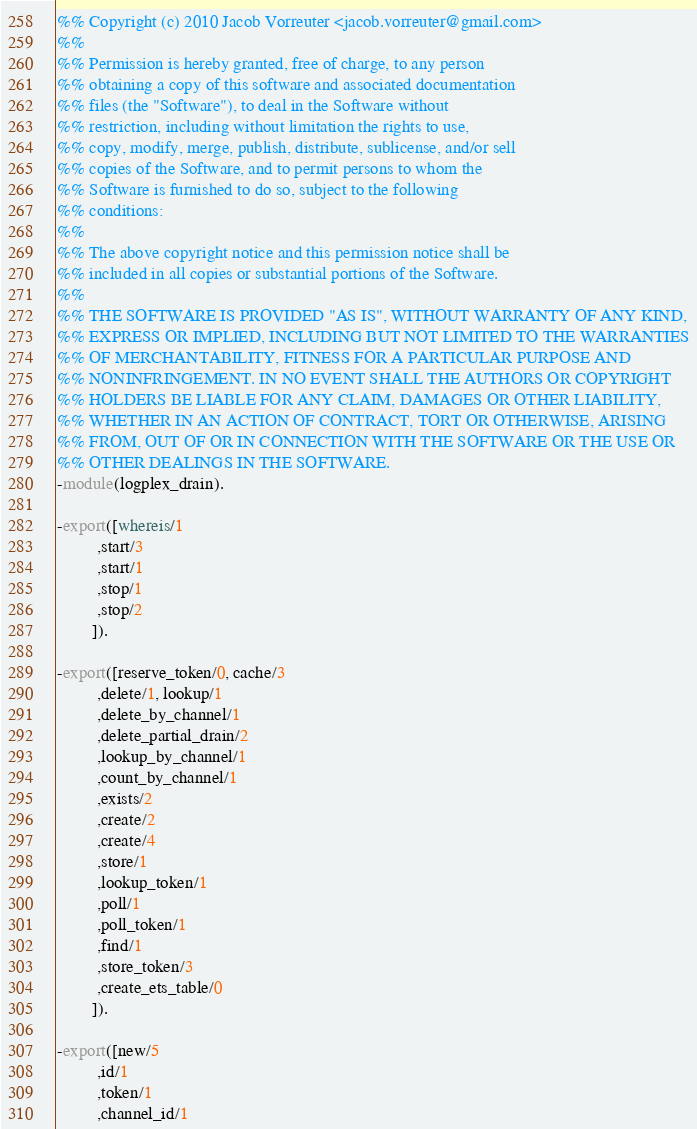<code> <loc_0><loc_0><loc_500><loc_500><_Erlang_>%% Copyright (c) 2010 Jacob Vorreuter <jacob.vorreuter@gmail.com>
%%
%% Permission is hereby granted, free of charge, to any person
%% obtaining a copy of this software and associated documentation
%% files (the "Software"), to deal in the Software without
%% restriction, including without limitation the rights to use,
%% copy, modify, merge, publish, distribute, sublicense, and/or sell
%% copies of the Software, and to permit persons to whom the
%% Software is furnished to do so, subject to the following
%% conditions:
%%
%% The above copyright notice and this permission notice shall be
%% included in all copies or substantial portions of the Software.
%%
%% THE SOFTWARE IS PROVIDED "AS IS", WITHOUT WARRANTY OF ANY KIND,
%% EXPRESS OR IMPLIED, INCLUDING BUT NOT LIMITED TO THE WARRANTIES
%% OF MERCHANTABILITY, FITNESS FOR A PARTICULAR PURPOSE AND
%% NONINFRINGEMENT. IN NO EVENT SHALL THE AUTHORS OR COPYRIGHT
%% HOLDERS BE LIABLE FOR ANY CLAIM, DAMAGES OR OTHER LIABILITY,
%% WHETHER IN AN ACTION OF CONTRACT, TORT OR OTHERWISE, ARISING
%% FROM, OUT OF OR IN CONNECTION WITH THE SOFTWARE OR THE USE OR
%% OTHER DEALINGS IN THE SOFTWARE.
-module(logplex_drain).

-export([whereis/1
         ,start/3
         ,start/1
         ,stop/1
         ,stop/2
        ]).

-export([reserve_token/0, cache/3
         ,delete/1, lookup/1
         ,delete_by_channel/1
         ,delete_partial_drain/2
         ,lookup_by_channel/1
         ,count_by_channel/1
         ,exists/2
         ,create/2
         ,create/4
         ,store/1
         ,lookup_token/1
         ,poll/1
         ,poll_token/1
         ,find/1
         ,store_token/3
         ,create_ets_table/0
        ]).

-export([new/5
         ,id/1
         ,token/1
         ,channel_id/1</code> 